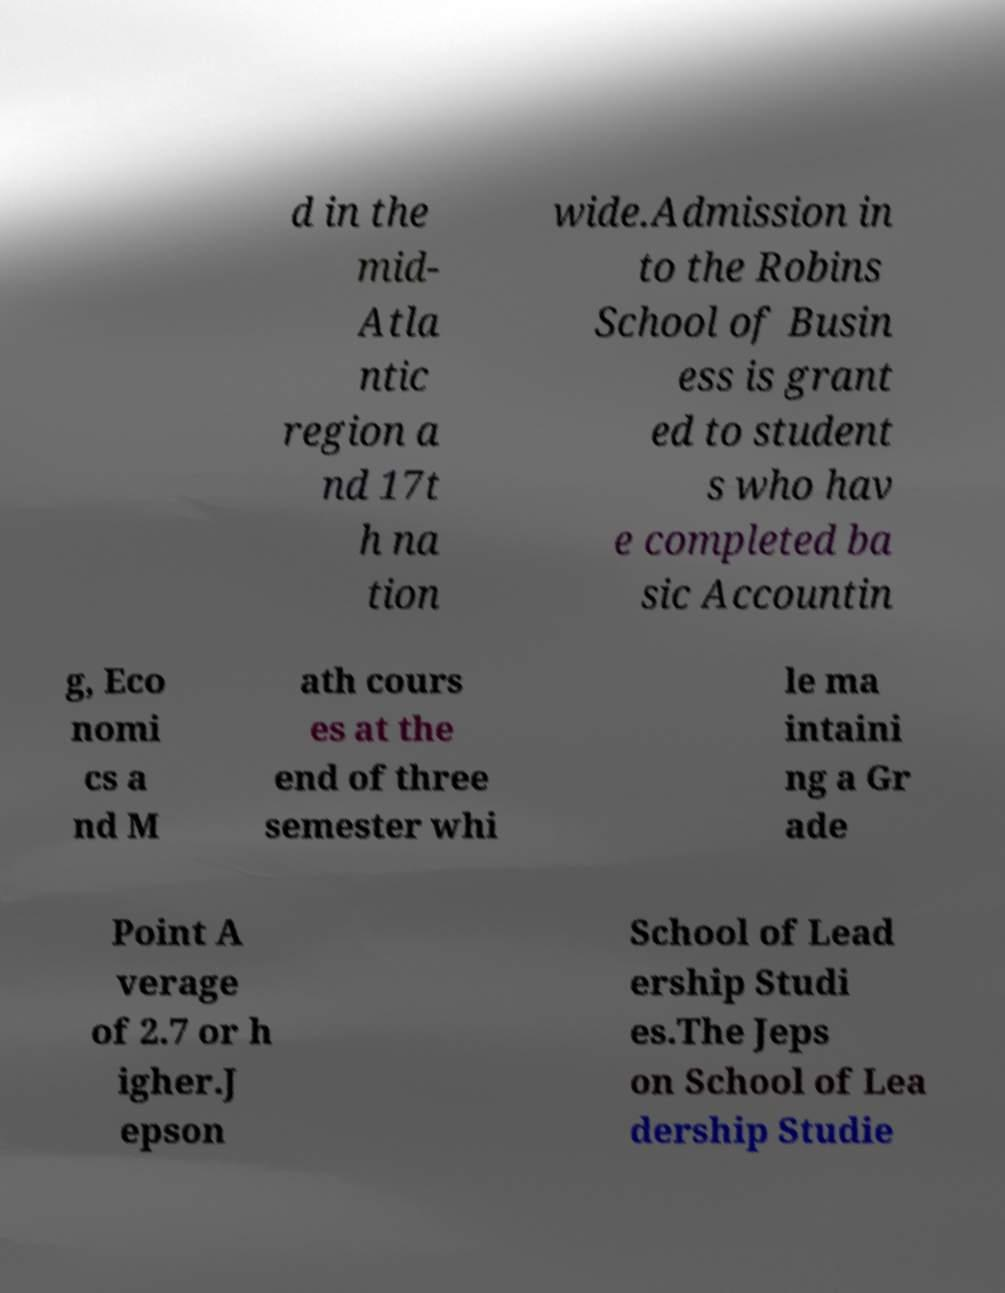Can you read and provide the text displayed in the image?This photo seems to have some interesting text. Can you extract and type it out for me? d in the mid- Atla ntic region a nd 17t h na tion wide.Admission in to the Robins School of Busin ess is grant ed to student s who hav e completed ba sic Accountin g, Eco nomi cs a nd M ath cours es at the end of three semester whi le ma intaini ng a Gr ade Point A verage of 2.7 or h igher.J epson School of Lead ership Studi es.The Jeps on School of Lea dership Studie 